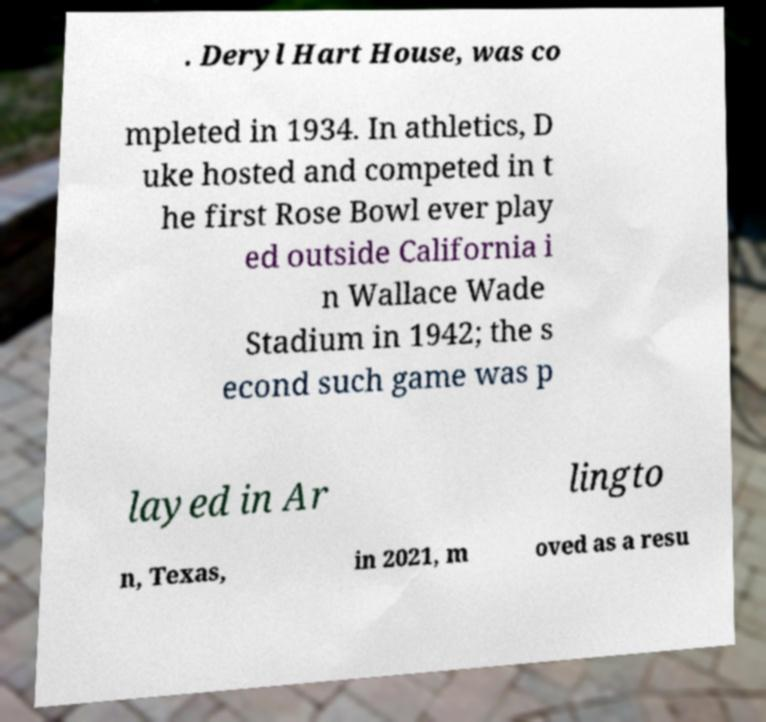Can you read and provide the text displayed in the image?This photo seems to have some interesting text. Can you extract and type it out for me? . Deryl Hart House, was co mpleted in 1934. In athletics, D uke hosted and competed in t he first Rose Bowl ever play ed outside California i n Wallace Wade Stadium in 1942; the s econd such game was p layed in Ar lingto n, Texas, in 2021, m oved as a resu 